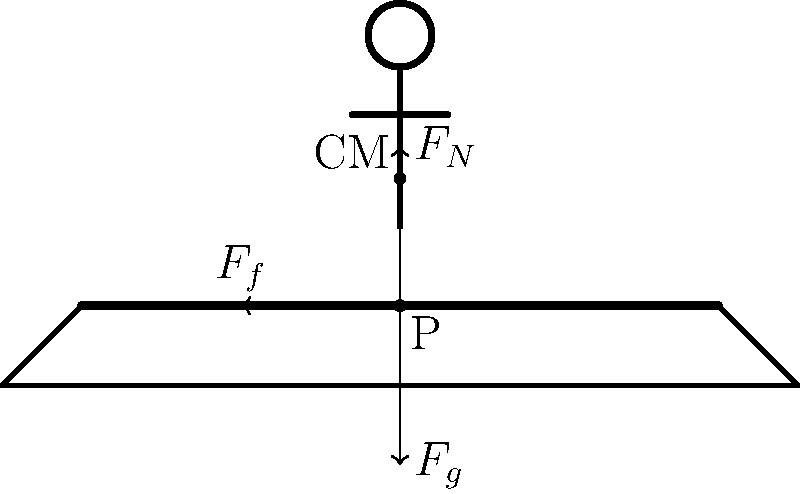In this political balancing act, our esteemed politician is teetering on the edge of public opinion. If the coefficient of friction between the politician's shoes and the platform is $\mu = 0.4$, what's the maximum angle $\theta$ the platform can tilt before our politician starts sliding into unemployment? Assume the politician's center of mass is directly above the pivot point. Let's break this down step by step, mixing a bit of physics with political humor:

1) For the politician to remain stationary, the forces must be balanced. The key forces are:
   - Normal force ($F_N$) perpendicular to the platform
   - Gravitational force ($F_g$) pulling straight down
   - Friction force ($F_f$) parallel to the platform, preventing sliding

2) When the platform is tilted at angle $\theta$, the components of the gravitational force are:
   - Parallel to the platform: $F_g \sin\theta$
   - Perpendicular to the platform: $F_g \cos\theta$

3) The normal force $F_N$ is equal to the perpendicular component of $F_g$:
   $F_N = F_g \cos\theta$

4) The maximum friction force is given by:
   $F_f = \mu F_N = \mu F_g \cos\theta$

5) At the point of sliding, the friction force equals the parallel component of gravity:
   $F_f = F_g \sin\theta$

6) Substituting from step 4:
   $\mu F_g \cos\theta = F_g \sin\theta$

7) The $F_g$ cancels out on both sides:
   $\mu \cos\theta = \sin\theta$

8) Dividing both sides by $\cos\theta$:
   $\mu = \tan\theta$

9) Taking the inverse tangent of both sides:
   $\theta = \tan^{-1}(\mu)$

10) Plugging in $\mu = 0.4$:
    $\theta = \tan^{-1}(0.4) \approx 21.8°$

So, like a politician trying to appeal to both sides of the aisle, our friend here can tilt about 21.8° before sliding into political obscurity!
Answer: $\theta = \tan^{-1}(0.4) \approx 21.8°$ 